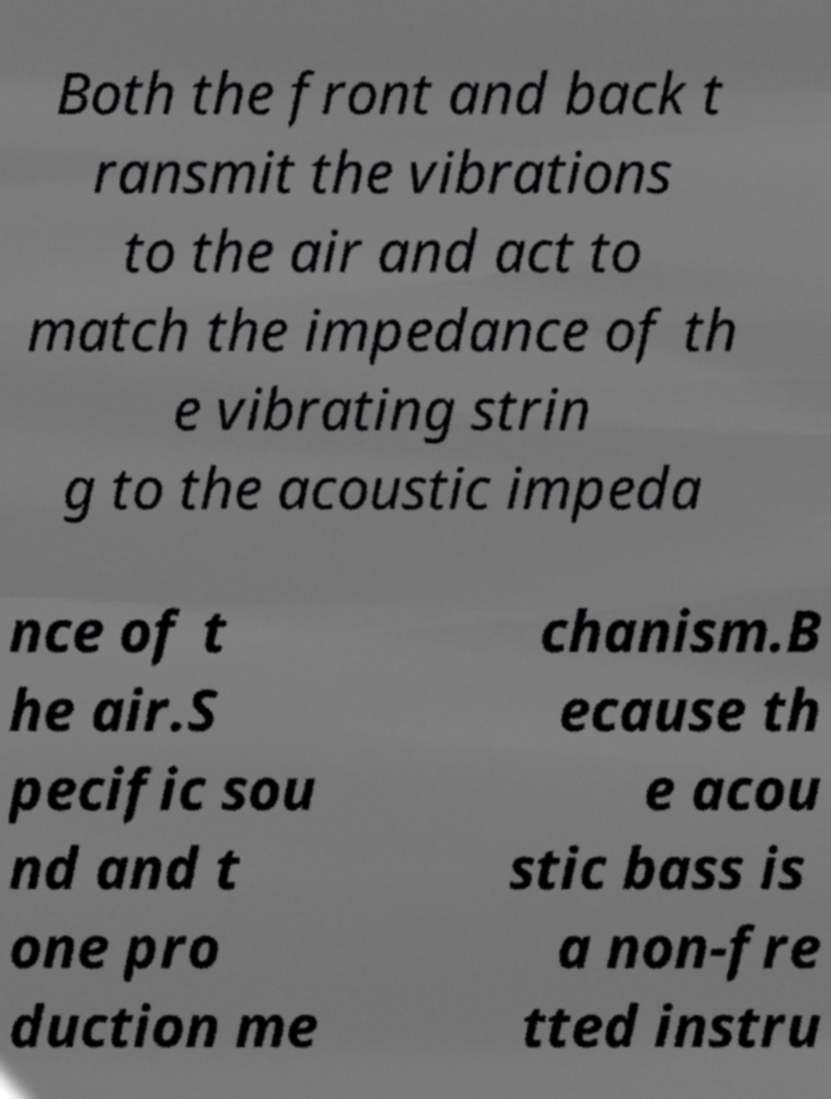Please identify and transcribe the text found in this image. Both the front and back t ransmit the vibrations to the air and act to match the impedance of th e vibrating strin g to the acoustic impeda nce of t he air.S pecific sou nd and t one pro duction me chanism.B ecause th e acou stic bass is a non-fre tted instru 